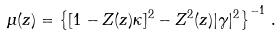Convert formula to latex. <formula><loc_0><loc_0><loc_500><loc_500>\mu ( z ) = \left \{ [ 1 - Z ( z ) \kappa ] ^ { 2 } - Z ^ { 2 } ( z ) | \gamma | ^ { 2 } \right \} ^ { - 1 } \, .</formula> 